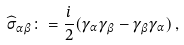Convert formula to latex. <formula><loc_0><loc_0><loc_500><loc_500>\widehat { \sigma } _ { \alpha \beta } \colon = \frac { i } { 2 } ( \gamma _ { \alpha } \gamma _ { \beta } - \gamma _ { \beta } \gamma _ { \alpha } ) \, ,</formula> 